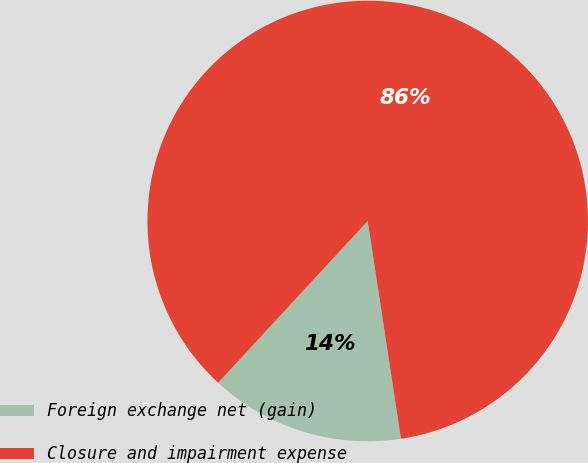Convert chart. <chart><loc_0><loc_0><loc_500><loc_500><pie_chart><fcel>Foreign exchange net (gain)<fcel>Closure and impairment expense<nl><fcel>14.29%<fcel>85.71%<nl></chart> 